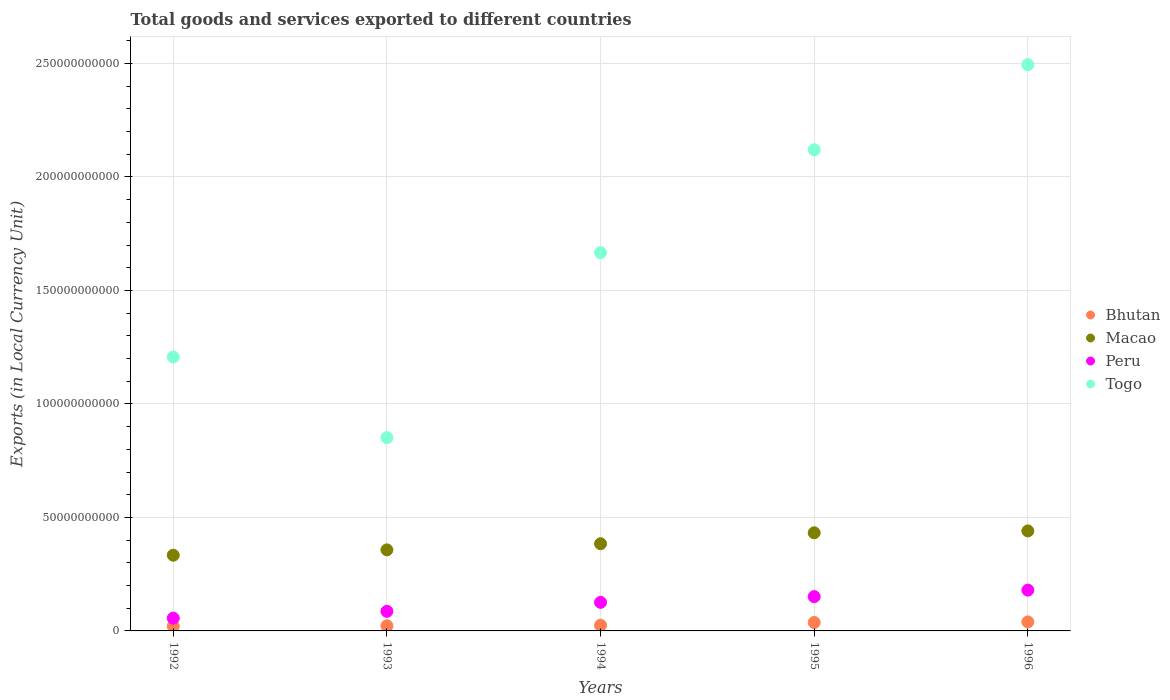What is the Amount of goods and services exports in Macao in 1995?
Offer a very short reply. 4.32e+1. Across all years, what is the maximum Amount of goods and services exports in Togo?
Your answer should be compact. 2.49e+11. Across all years, what is the minimum Amount of goods and services exports in Bhutan?
Make the answer very short. 2.08e+09. In which year was the Amount of goods and services exports in Togo maximum?
Provide a short and direct response. 1996. In which year was the Amount of goods and services exports in Togo minimum?
Give a very brief answer. 1993. What is the total Amount of goods and services exports in Peru in the graph?
Make the answer very short. 5.99e+1. What is the difference between the Amount of goods and services exports in Macao in 1993 and that in 1994?
Your answer should be compact. -2.71e+09. What is the difference between the Amount of goods and services exports in Peru in 1992 and the Amount of goods and services exports in Macao in 1996?
Provide a short and direct response. -3.84e+1. What is the average Amount of goods and services exports in Bhutan per year?
Make the answer very short. 2.91e+09. In the year 1994, what is the difference between the Amount of goods and services exports in Macao and Amount of goods and services exports in Bhutan?
Ensure brevity in your answer.  3.59e+1. In how many years, is the Amount of goods and services exports in Macao greater than 220000000000 LCU?
Ensure brevity in your answer.  0. What is the ratio of the Amount of goods and services exports in Togo in 1992 to that in 1994?
Provide a short and direct response. 0.72. Is the Amount of goods and services exports in Bhutan in 1994 less than that in 1996?
Your response must be concise. Yes. Is the difference between the Amount of goods and services exports in Macao in 1995 and 1996 greater than the difference between the Amount of goods and services exports in Bhutan in 1995 and 1996?
Ensure brevity in your answer.  No. What is the difference between the highest and the second highest Amount of goods and services exports in Bhutan?
Make the answer very short. 2.67e+08. What is the difference between the highest and the lowest Amount of goods and services exports in Macao?
Make the answer very short. 1.07e+1. In how many years, is the Amount of goods and services exports in Peru greater than the average Amount of goods and services exports in Peru taken over all years?
Offer a very short reply. 3. Is the sum of the Amount of goods and services exports in Bhutan in 1993 and 1996 greater than the maximum Amount of goods and services exports in Peru across all years?
Your response must be concise. No. Is it the case that in every year, the sum of the Amount of goods and services exports in Peru and Amount of goods and services exports in Bhutan  is greater than the sum of Amount of goods and services exports in Togo and Amount of goods and services exports in Macao?
Your answer should be compact. Yes. Does the Amount of goods and services exports in Macao monotonically increase over the years?
Offer a very short reply. Yes. What is the difference between two consecutive major ticks on the Y-axis?
Your answer should be very brief. 5.00e+1. Are the values on the major ticks of Y-axis written in scientific E-notation?
Ensure brevity in your answer.  No. Does the graph contain any zero values?
Keep it short and to the point. No. Does the graph contain grids?
Provide a succinct answer. Yes. Where does the legend appear in the graph?
Ensure brevity in your answer.  Center right. What is the title of the graph?
Offer a very short reply. Total goods and services exported to different countries. What is the label or title of the Y-axis?
Your response must be concise. Exports (in Local Currency Unit). What is the Exports (in Local Currency Unit) of Bhutan in 1992?
Give a very brief answer. 2.08e+09. What is the Exports (in Local Currency Unit) in Macao in 1992?
Your answer should be compact. 3.34e+1. What is the Exports (in Local Currency Unit) of Peru in 1992?
Provide a succinct answer. 5.63e+09. What is the Exports (in Local Currency Unit) of Togo in 1992?
Provide a short and direct response. 1.21e+11. What is the Exports (in Local Currency Unit) in Bhutan in 1993?
Your answer should be compact. 2.26e+09. What is the Exports (in Local Currency Unit) in Macao in 1993?
Make the answer very short. 3.57e+1. What is the Exports (in Local Currency Unit) in Peru in 1993?
Offer a terse response. 8.63e+09. What is the Exports (in Local Currency Unit) in Togo in 1993?
Offer a terse response. 8.52e+1. What is the Exports (in Local Currency Unit) in Bhutan in 1994?
Provide a succinct answer. 2.51e+09. What is the Exports (in Local Currency Unit) in Macao in 1994?
Offer a very short reply. 3.84e+1. What is the Exports (in Local Currency Unit) of Peru in 1994?
Your answer should be compact. 1.26e+1. What is the Exports (in Local Currency Unit) of Togo in 1994?
Keep it short and to the point. 1.67e+11. What is the Exports (in Local Currency Unit) of Bhutan in 1995?
Your response must be concise. 3.71e+09. What is the Exports (in Local Currency Unit) of Macao in 1995?
Keep it short and to the point. 4.32e+1. What is the Exports (in Local Currency Unit) of Peru in 1995?
Keep it short and to the point. 1.51e+1. What is the Exports (in Local Currency Unit) of Togo in 1995?
Your answer should be compact. 2.12e+11. What is the Exports (in Local Currency Unit) in Bhutan in 1996?
Ensure brevity in your answer.  3.98e+09. What is the Exports (in Local Currency Unit) of Macao in 1996?
Offer a very short reply. 4.41e+1. What is the Exports (in Local Currency Unit) in Peru in 1996?
Provide a succinct answer. 1.80e+1. What is the Exports (in Local Currency Unit) in Togo in 1996?
Provide a succinct answer. 2.49e+11. Across all years, what is the maximum Exports (in Local Currency Unit) of Bhutan?
Your answer should be very brief. 3.98e+09. Across all years, what is the maximum Exports (in Local Currency Unit) in Macao?
Keep it short and to the point. 4.41e+1. Across all years, what is the maximum Exports (in Local Currency Unit) in Peru?
Offer a terse response. 1.80e+1. Across all years, what is the maximum Exports (in Local Currency Unit) of Togo?
Keep it short and to the point. 2.49e+11. Across all years, what is the minimum Exports (in Local Currency Unit) of Bhutan?
Your answer should be very brief. 2.08e+09. Across all years, what is the minimum Exports (in Local Currency Unit) in Macao?
Offer a very short reply. 3.34e+1. Across all years, what is the minimum Exports (in Local Currency Unit) of Peru?
Make the answer very short. 5.63e+09. Across all years, what is the minimum Exports (in Local Currency Unit) of Togo?
Give a very brief answer. 8.52e+1. What is the total Exports (in Local Currency Unit) of Bhutan in the graph?
Offer a terse response. 1.45e+1. What is the total Exports (in Local Currency Unit) of Macao in the graph?
Your answer should be compact. 1.95e+11. What is the total Exports (in Local Currency Unit) in Peru in the graph?
Provide a short and direct response. 5.99e+1. What is the total Exports (in Local Currency Unit) of Togo in the graph?
Your response must be concise. 8.34e+11. What is the difference between the Exports (in Local Currency Unit) in Bhutan in 1992 and that in 1993?
Your answer should be compact. -1.85e+08. What is the difference between the Exports (in Local Currency Unit) in Macao in 1992 and that in 1993?
Your answer should be compact. -2.35e+09. What is the difference between the Exports (in Local Currency Unit) of Peru in 1992 and that in 1993?
Provide a short and direct response. -3.00e+09. What is the difference between the Exports (in Local Currency Unit) in Togo in 1992 and that in 1993?
Your answer should be very brief. 3.55e+1. What is the difference between the Exports (in Local Currency Unit) of Bhutan in 1992 and that in 1994?
Your answer should be compact. -4.29e+08. What is the difference between the Exports (in Local Currency Unit) of Macao in 1992 and that in 1994?
Offer a terse response. -5.06e+09. What is the difference between the Exports (in Local Currency Unit) in Peru in 1992 and that in 1994?
Ensure brevity in your answer.  -6.96e+09. What is the difference between the Exports (in Local Currency Unit) in Togo in 1992 and that in 1994?
Make the answer very short. -4.60e+1. What is the difference between the Exports (in Local Currency Unit) of Bhutan in 1992 and that in 1995?
Keep it short and to the point. -1.63e+09. What is the difference between the Exports (in Local Currency Unit) of Macao in 1992 and that in 1995?
Provide a succinct answer. -9.87e+09. What is the difference between the Exports (in Local Currency Unit) of Peru in 1992 and that in 1995?
Offer a terse response. -9.49e+09. What is the difference between the Exports (in Local Currency Unit) in Togo in 1992 and that in 1995?
Your response must be concise. -9.13e+1. What is the difference between the Exports (in Local Currency Unit) of Bhutan in 1992 and that in 1996?
Provide a short and direct response. -1.90e+09. What is the difference between the Exports (in Local Currency Unit) in Macao in 1992 and that in 1996?
Ensure brevity in your answer.  -1.07e+1. What is the difference between the Exports (in Local Currency Unit) of Peru in 1992 and that in 1996?
Your response must be concise. -1.23e+1. What is the difference between the Exports (in Local Currency Unit) in Togo in 1992 and that in 1996?
Offer a terse response. -1.29e+11. What is the difference between the Exports (in Local Currency Unit) in Bhutan in 1993 and that in 1994?
Make the answer very short. -2.44e+08. What is the difference between the Exports (in Local Currency Unit) of Macao in 1993 and that in 1994?
Make the answer very short. -2.71e+09. What is the difference between the Exports (in Local Currency Unit) in Peru in 1993 and that in 1994?
Provide a succinct answer. -3.96e+09. What is the difference between the Exports (in Local Currency Unit) of Togo in 1993 and that in 1994?
Your answer should be compact. -8.15e+1. What is the difference between the Exports (in Local Currency Unit) in Bhutan in 1993 and that in 1995?
Make the answer very short. -1.45e+09. What is the difference between the Exports (in Local Currency Unit) in Macao in 1993 and that in 1995?
Your response must be concise. -7.52e+09. What is the difference between the Exports (in Local Currency Unit) of Peru in 1993 and that in 1995?
Provide a short and direct response. -6.49e+09. What is the difference between the Exports (in Local Currency Unit) of Togo in 1993 and that in 1995?
Provide a short and direct response. -1.27e+11. What is the difference between the Exports (in Local Currency Unit) in Bhutan in 1993 and that in 1996?
Ensure brevity in your answer.  -1.71e+09. What is the difference between the Exports (in Local Currency Unit) in Macao in 1993 and that in 1996?
Your answer should be very brief. -8.35e+09. What is the difference between the Exports (in Local Currency Unit) of Peru in 1993 and that in 1996?
Offer a very short reply. -9.35e+09. What is the difference between the Exports (in Local Currency Unit) of Togo in 1993 and that in 1996?
Offer a very short reply. -1.64e+11. What is the difference between the Exports (in Local Currency Unit) in Bhutan in 1994 and that in 1995?
Your answer should be very brief. -1.20e+09. What is the difference between the Exports (in Local Currency Unit) in Macao in 1994 and that in 1995?
Provide a short and direct response. -4.81e+09. What is the difference between the Exports (in Local Currency Unit) of Peru in 1994 and that in 1995?
Keep it short and to the point. -2.53e+09. What is the difference between the Exports (in Local Currency Unit) of Togo in 1994 and that in 1995?
Provide a short and direct response. -4.53e+1. What is the difference between the Exports (in Local Currency Unit) in Bhutan in 1994 and that in 1996?
Your answer should be compact. -1.47e+09. What is the difference between the Exports (in Local Currency Unit) of Macao in 1994 and that in 1996?
Give a very brief answer. -5.64e+09. What is the difference between the Exports (in Local Currency Unit) in Peru in 1994 and that in 1996?
Offer a very short reply. -5.38e+09. What is the difference between the Exports (in Local Currency Unit) of Togo in 1994 and that in 1996?
Your response must be concise. -8.28e+1. What is the difference between the Exports (in Local Currency Unit) in Bhutan in 1995 and that in 1996?
Make the answer very short. -2.67e+08. What is the difference between the Exports (in Local Currency Unit) of Macao in 1995 and that in 1996?
Make the answer very short. -8.31e+08. What is the difference between the Exports (in Local Currency Unit) of Peru in 1995 and that in 1996?
Give a very brief answer. -2.86e+09. What is the difference between the Exports (in Local Currency Unit) of Togo in 1995 and that in 1996?
Offer a very short reply. -3.75e+1. What is the difference between the Exports (in Local Currency Unit) of Bhutan in 1992 and the Exports (in Local Currency Unit) of Macao in 1993?
Offer a terse response. -3.36e+1. What is the difference between the Exports (in Local Currency Unit) in Bhutan in 1992 and the Exports (in Local Currency Unit) in Peru in 1993?
Give a very brief answer. -6.55e+09. What is the difference between the Exports (in Local Currency Unit) in Bhutan in 1992 and the Exports (in Local Currency Unit) in Togo in 1993?
Offer a terse response. -8.31e+1. What is the difference between the Exports (in Local Currency Unit) in Macao in 1992 and the Exports (in Local Currency Unit) in Peru in 1993?
Offer a very short reply. 2.47e+1. What is the difference between the Exports (in Local Currency Unit) in Macao in 1992 and the Exports (in Local Currency Unit) in Togo in 1993?
Offer a terse response. -5.18e+1. What is the difference between the Exports (in Local Currency Unit) of Peru in 1992 and the Exports (in Local Currency Unit) of Togo in 1993?
Provide a short and direct response. -7.95e+1. What is the difference between the Exports (in Local Currency Unit) of Bhutan in 1992 and the Exports (in Local Currency Unit) of Macao in 1994?
Keep it short and to the point. -3.63e+1. What is the difference between the Exports (in Local Currency Unit) in Bhutan in 1992 and the Exports (in Local Currency Unit) in Peru in 1994?
Your answer should be very brief. -1.05e+1. What is the difference between the Exports (in Local Currency Unit) in Bhutan in 1992 and the Exports (in Local Currency Unit) in Togo in 1994?
Your answer should be compact. -1.65e+11. What is the difference between the Exports (in Local Currency Unit) in Macao in 1992 and the Exports (in Local Currency Unit) in Peru in 1994?
Your response must be concise. 2.08e+1. What is the difference between the Exports (in Local Currency Unit) in Macao in 1992 and the Exports (in Local Currency Unit) in Togo in 1994?
Provide a succinct answer. -1.33e+11. What is the difference between the Exports (in Local Currency Unit) of Peru in 1992 and the Exports (in Local Currency Unit) of Togo in 1994?
Offer a terse response. -1.61e+11. What is the difference between the Exports (in Local Currency Unit) in Bhutan in 1992 and the Exports (in Local Currency Unit) in Macao in 1995?
Your answer should be compact. -4.12e+1. What is the difference between the Exports (in Local Currency Unit) in Bhutan in 1992 and the Exports (in Local Currency Unit) in Peru in 1995?
Keep it short and to the point. -1.30e+1. What is the difference between the Exports (in Local Currency Unit) in Bhutan in 1992 and the Exports (in Local Currency Unit) in Togo in 1995?
Provide a succinct answer. -2.10e+11. What is the difference between the Exports (in Local Currency Unit) of Macao in 1992 and the Exports (in Local Currency Unit) of Peru in 1995?
Make the answer very short. 1.82e+1. What is the difference between the Exports (in Local Currency Unit) of Macao in 1992 and the Exports (in Local Currency Unit) of Togo in 1995?
Provide a succinct answer. -1.79e+11. What is the difference between the Exports (in Local Currency Unit) of Peru in 1992 and the Exports (in Local Currency Unit) of Togo in 1995?
Give a very brief answer. -2.06e+11. What is the difference between the Exports (in Local Currency Unit) of Bhutan in 1992 and the Exports (in Local Currency Unit) of Macao in 1996?
Give a very brief answer. -4.20e+1. What is the difference between the Exports (in Local Currency Unit) in Bhutan in 1992 and the Exports (in Local Currency Unit) in Peru in 1996?
Your answer should be very brief. -1.59e+1. What is the difference between the Exports (in Local Currency Unit) of Bhutan in 1992 and the Exports (in Local Currency Unit) of Togo in 1996?
Ensure brevity in your answer.  -2.47e+11. What is the difference between the Exports (in Local Currency Unit) in Macao in 1992 and the Exports (in Local Currency Unit) in Peru in 1996?
Ensure brevity in your answer.  1.54e+1. What is the difference between the Exports (in Local Currency Unit) in Macao in 1992 and the Exports (in Local Currency Unit) in Togo in 1996?
Give a very brief answer. -2.16e+11. What is the difference between the Exports (in Local Currency Unit) of Peru in 1992 and the Exports (in Local Currency Unit) of Togo in 1996?
Give a very brief answer. -2.44e+11. What is the difference between the Exports (in Local Currency Unit) in Bhutan in 1993 and the Exports (in Local Currency Unit) in Macao in 1994?
Provide a succinct answer. -3.62e+1. What is the difference between the Exports (in Local Currency Unit) in Bhutan in 1993 and the Exports (in Local Currency Unit) in Peru in 1994?
Keep it short and to the point. -1.03e+1. What is the difference between the Exports (in Local Currency Unit) of Bhutan in 1993 and the Exports (in Local Currency Unit) of Togo in 1994?
Offer a very short reply. -1.64e+11. What is the difference between the Exports (in Local Currency Unit) of Macao in 1993 and the Exports (in Local Currency Unit) of Peru in 1994?
Ensure brevity in your answer.  2.31e+1. What is the difference between the Exports (in Local Currency Unit) of Macao in 1993 and the Exports (in Local Currency Unit) of Togo in 1994?
Keep it short and to the point. -1.31e+11. What is the difference between the Exports (in Local Currency Unit) of Peru in 1993 and the Exports (in Local Currency Unit) of Togo in 1994?
Make the answer very short. -1.58e+11. What is the difference between the Exports (in Local Currency Unit) in Bhutan in 1993 and the Exports (in Local Currency Unit) in Macao in 1995?
Provide a short and direct response. -4.10e+1. What is the difference between the Exports (in Local Currency Unit) in Bhutan in 1993 and the Exports (in Local Currency Unit) in Peru in 1995?
Provide a short and direct response. -1.29e+1. What is the difference between the Exports (in Local Currency Unit) of Bhutan in 1993 and the Exports (in Local Currency Unit) of Togo in 1995?
Your response must be concise. -2.10e+11. What is the difference between the Exports (in Local Currency Unit) in Macao in 1993 and the Exports (in Local Currency Unit) in Peru in 1995?
Your response must be concise. 2.06e+1. What is the difference between the Exports (in Local Currency Unit) of Macao in 1993 and the Exports (in Local Currency Unit) of Togo in 1995?
Make the answer very short. -1.76e+11. What is the difference between the Exports (in Local Currency Unit) in Peru in 1993 and the Exports (in Local Currency Unit) in Togo in 1995?
Your answer should be very brief. -2.03e+11. What is the difference between the Exports (in Local Currency Unit) in Bhutan in 1993 and the Exports (in Local Currency Unit) in Macao in 1996?
Ensure brevity in your answer.  -4.18e+1. What is the difference between the Exports (in Local Currency Unit) in Bhutan in 1993 and the Exports (in Local Currency Unit) in Peru in 1996?
Keep it short and to the point. -1.57e+1. What is the difference between the Exports (in Local Currency Unit) of Bhutan in 1993 and the Exports (in Local Currency Unit) of Togo in 1996?
Your answer should be compact. -2.47e+11. What is the difference between the Exports (in Local Currency Unit) in Macao in 1993 and the Exports (in Local Currency Unit) in Peru in 1996?
Your answer should be compact. 1.77e+1. What is the difference between the Exports (in Local Currency Unit) in Macao in 1993 and the Exports (in Local Currency Unit) in Togo in 1996?
Keep it short and to the point. -2.14e+11. What is the difference between the Exports (in Local Currency Unit) of Peru in 1993 and the Exports (in Local Currency Unit) of Togo in 1996?
Provide a succinct answer. -2.41e+11. What is the difference between the Exports (in Local Currency Unit) of Bhutan in 1994 and the Exports (in Local Currency Unit) of Macao in 1995?
Your answer should be very brief. -4.07e+1. What is the difference between the Exports (in Local Currency Unit) of Bhutan in 1994 and the Exports (in Local Currency Unit) of Peru in 1995?
Your response must be concise. -1.26e+1. What is the difference between the Exports (in Local Currency Unit) in Bhutan in 1994 and the Exports (in Local Currency Unit) in Togo in 1995?
Offer a very short reply. -2.09e+11. What is the difference between the Exports (in Local Currency Unit) of Macao in 1994 and the Exports (in Local Currency Unit) of Peru in 1995?
Give a very brief answer. 2.33e+1. What is the difference between the Exports (in Local Currency Unit) in Macao in 1994 and the Exports (in Local Currency Unit) in Togo in 1995?
Offer a very short reply. -1.74e+11. What is the difference between the Exports (in Local Currency Unit) in Peru in 1994 and the Exports (in Local Currency Unit) in Togo in 1995?
Offer a very short reply. -1.99e+11. What is the difference between the Exports (in Local Currency Unit) of Bhutan in 1994 and the Exports (in Local Currency Unit) of Macao in 1996?
Your answer should be very brief. -4.16e+1. What is the difference between the Exports (in Local Currency Unit) of Bhutan in 1994 and the Exports (in Local Currency Unit) of Peru in 1996?
Ensure brevity in your answer.  -1.55e+1. What is the difference between the Exports (in Local Currency Unit) in Bhutan in 1994 and the Exports (in Local Currency Unit) in Togo in 1996?
Your response must be concise. -2.47e+11. What is the difference between the Exports (in Local Currency Unit) in Macao in 1994 and the Exports (in Local Currency Unit) in Peru in 1996?
Your response must be concise. 2.04e+1. What is the difference between the Exports (in Local Currency Unit) of Macao in 1994 and the Exports (in Local Currency Unit) of Togo in 1996?
Provide a succinct answer. -2.11e+11. What is the difference between the Exports (in Local Currency Unit) of Peru in 1994 and the Exports (in Local Currency Unit) of Togo in 1996?
Provide a succinct answer. -2.37e+11. What is the difference between the Exports (in Local Currency Unit) of Bhutan in 1995 and the Exports (in Local Currency Unit) of Macao in 1996?
Your response must be concise. -4.04e+1. What is the difference between the Exports (in Local Currency Unit) in Bhutan in 1995 and the Exports (in Local Currency Unit) in Peru in 1996?
Provide a short and direct response. -1.43e+1. What is the difference between the Exports (in Local Currency Unit) of Bhutan in 1995 and the Exports (in Local Currency Unit) of Togo in 1996?
Keep it short and to the point. -2.46e+11. What is the difference between the Exports (in Local Currency Unit) in Macao in 1995 and the Exports (in Local Currency Unit) in Peru in 1996?
Provide a short and direct response. 2.53e+1. What is the difference between the Exports (in Local Currency Unit) of Macao in 1995 and the Exports (in Local Currency Unit) of Togo in 1996?
Your answer should be very brief. -2.06e+11. What is the difference between the Exports (in Local Currency Unit) in Peru in 1995 and the Exports (in Local Currency Unit) in Togo in 1996?
Provide a short and direct response. -2.34e+11. What is the average Exports (in Local Currency Unit) in Bhutan per year?
Your response must be concise. 2.91e+09. What is the average Exports (in Local Currency Unit) of Macao per year?
Offer a very short reply. 3.90e+1. What is the average Exports (in Local Currency Unit) in Peru per year?
Give a very brief answer. 1.20e+1. What is the average Exports (in Local Currency Unit) in Togo per year?
Your response must be concise. 1.67e+11. In the year 1992, what is the difference between the Exports (in Local Currency Unit) of Bhutan and Exports (in Local Currency Unit) of Macao?
Your answer should be very brief. -3.13e+1. In the year 1992, what is the difference between the Exports (in Local Currency Unit) in Bhutan and Exports (in Local Currency Unit) in Peru?
Offer a terse response. -3.55e+09. In the year 1992, what is the difference between the Exports (in Local Currency Unit) of Bhutan and Exports (in Local Currency Unit) of Togo?
Keep it short and to the point. -1.19e+11. In the year 1992, what is the difference between the Exports (in Local Currency Unit) in Macao and Exports (in Local Currency Unit) in Peru?
Make the answer very short. 2.77e+1. In the year 1992, what is the difference between the Exports (in Local Currency Unit) of Macao and Exports (in Local Currency Unit) of Togo?
Your answer should be compact. -8.73e+1. In the year 1992, what is the difference between the Exports (in Local Currency Unit) of Peru and Exports (in Local Currency Unit) of Togo?
Provide a short and direct response. -1.15e+11. In the year 1993, what is the difference between the Exports (in Local Currency Unit) in Bhutan and Exports (in Local Currency Unit) in Macao?
Provide a short and direct response. -3.34e+1. In the year 1993, what is the difference between the Exports (in Local Currency Unit) of Bhutan and Exports (in Local Currency Unit) of Peru?
Your answer should be compact. -6.36e+09. In the year 1993, what is the difference between the Exports (in Local Currency Unit) of Bhutan and Exports (in Local Currency Unit) of Togo?
Provide a short and direct response. -8.29e+1. In the year 1993, what is the difference between the Exports (in Local Currency Unit) in Macao and Exports (in Local Currency Unit) in Peru?
Ensure brevity in your answer.  2.71e+1. In the year 1993, what is the difference between the Exports (in Local Currency Unit) of Macao and Exports (in Local Currency Unit) of Togo?
Offer a terse response. -4.95e+1. In the year 1993, what is the difference between the Exports (in Local Currency Unit) of Peru and Exports (in Local Currency Unit) of Togo?
Your answer should be very brief. -7.65e+1. In the year 1994, what is the difference between the Exports (in Local Currency Unit) of Bhutan and Exports (in Local Currency Unit) of Macao?
Keep it short and to the point. -3.59e+1. In the year 1994, what is the difference between the Exports (in Local Currency Unit) of Bhutan and Exports (in Local Currency Unit) of Peru?
Offer a very short reply. -1.01e+1. In the year 1994, what is the difference between the Exports (in Local Currency Unit) of Bhutan and Exports (in Local Currency Unit) of Togo?
Your response must be concise. -1.64e+11. In the year 1994, what is the difference between the Exports (in Local Currency Unit) of Macao and Exports (in Local Currency Unit) of Peru?
Your answer should be very brief. 2.58e+1. In the year 1994, what is the difference between the Exports (in Local Currency Unit) in Macao and Exports (in Local Currency Unit) in Togo?
Offer a terse response. -1.28e+11. In the year 1994, what is the difference between the Exports (in Local Currency Unit) in Peru and Exports (in Local Currency Unit) in Togo?
Keep it short and to the point. -1.54e+11. In the year 1995, what is the difference between the Exports (in Local Currency Unit) of Bhutan and Exports (in Local Currency Unit) of Macao?
Your answer should be compact. -3.95e+1. In the year 1995, what is the difference between the Exports (in Local Currency Unit) of Bhutan and Exports (in Local Currency Unit) of Peru?
Offer a terse response. -1.14e+1. In the year 1995, what is the difference between the Exports (in Local Currency Unit) of Bhutan and Exports (in Local Currency Unit) of Togo?
Your answer should be compact. -2.08e+11. In the year 1995, what is the difference between the Exports (in Local Currency Unit) in Macao and Exports (in Local Currency Unit) in Peru?
Ensure brevity in your answer.  2.81e+1. In the year 1995, what is the difference between the Exports (in Local Currency Unit) in Macao and Exports (in Local Currency Unit) in Togo?
Provide a succinct answer. -1.69e+11. In the year 1995, what is the difference between the Exports (in Local Currency Unit) in Peru and Exports (in Local Currency Unit) in Togo?
Keep it short and to the point. -1.97e+11. In the year 1996, what is the difference between the Exports (in Local Currency Unit) of Bhutan and Exports (in Local Currency Unit) of Macao?
Offer a very short reply. -4.01e+1. In the year 1996, what is the difference between the Exports (in Local Currency Unit) in Bhutan and Exports (in Local Currency Unit) in Peru?
Keep it short and to the point. -1.40e+1. In the year 1996, what is the difference between the Exports (in Local Currency Unit) in Bhutan and Exports (in Local Currency Unit) in Togo?
Make the answer very short. -2.46e+11. In the year 1996, what is the difference between the Exports (in Local Currency Unit) in Macao and Exports (in Local Currency Unit) in Peru?
Make the answer very short. 2.61e+1. In the year 1996, what is the difference between the Exports (in Local Currency Unit) in Macao and Exports (in Local Currency Unit) in Togo?
Provide a succinct answer. -2.05e+11. In the year 1996, what is the difference between the Exports (in Local Currency Unit) in Peru and Exports (in Local Currency Unit) in Togo?
Offer a terse response. -2.32e+11. What is the ratio of the Exports (in Local Currency Unit) in Bhutan in 1992 to that in 1993?
Ensure brevity in your answer.  0.92. What is the ratio of the Exports (in Local Currency Unit) of Macao in 1992 to that in 1993?
Your answer should be compact. 0.93. What is the ratio of the Exports (in Local Currency Unit) in Peru in 1992 to that in 1993?
Provide a short and direct response. 0.65. What is the ratio of the Exports (in Local Currency Unit) of Togo in 1992 to that in 1993?
Offer a very short reply. 1.42. What is the ratio of the Exports (in Local Currency Unit) of Bhutan in 1992 to that in 1994?
Your answer should be very brief. 0.83. What is the ratio of the Exports (in Local Currency Unit) of Macao in 1992 to that in 1994?
Ensure brevity in your answer.  0.87. What is the ratio of the Exports (in Local Currency Unit) in Peru in 1992 to that in 1994?
Offer a terse response. 0.45. What is the ratio of the Exports (in Local Currency Unit) of Togo in 1992 to that in 1994?
Offer a very short reply. 0.72. What is the ratio of the Exports (in Local Currency Unit) of Bhutan in 1992 to that in 1995?
Give a very brief answer. 0.56. What is the ratio of the Exports (in Local Currency Unit) of Macao in 1992 to that in 1995?
Ensure brevity in your answer.  0.77. What is the ratio of the Exports (in Local Currency Unit) in Peru in 1992 to that in 1995?
Ensure brevity in your answer.  0.37. What is the ratio of the Exports (in Local Currency Unit) in Togo in 1992 to that in 1995?
Your response must be concise. 0.57. What is the ratio of the Exports (in Local Currency Unit) in Bhutan in 1992 to that in 1996?
Keep it short and to the point. 0.52. What is the ratio of the Exports (in Local Currency Unit) of Macao in 1992 to that in 1996?
Keep it short and to the point. 0.76. What is the ratio of the Exports (in Local Currency Unit) in Peru in 1992 to that in 1996?
Make the answer very short. 0.31. What is the ratio of the Exports (in Local Currency Unit) in Togo in 1992 to that in 1996?
Provide a succinct answer. 0.48. What is the ratio of the Exports (in Local Currency Unit) of Bhutan in 1993 to that in 1994?
Offer a very short reply. 0.9. What is the ratio of the Exports (in Local Currency Unit) in Macao in 1993 to that in 1994?
Your answer should be compact. 0.93. What is the ratio of the Exports (in Local Currency Unit) of Peru in 1993 to that in 1994?
Your answer should be very brief. 0.69. What is the ratio of the Exports (in Local Currency Unit) in Togo in 1993 to that in 1994?
Keep it short and to the point. 0.51. What is the ratio of the Exports (in Local Currency Unit) of Bhutan in 1993 to that in 1995?
Offer a terse response. 0.61. What is the ratio of the Exports (in Local Currency Unit) of Macao in 1993 to that in 1995?
Make the answer very short. 0.83. What is the ratio of the Exports (in Local Currency Unit) of Peru in 1993 to that in 1995?
Offer a very short reply. 0.57. What is the ratio of the Exports (in Local Currency Unit) in Togo in 1993 to that in 1995?
Keep it short and to the point. 0.4. What is the ratio of the Exports (in Local Currency Unit) in Bhutan in 1993 to that in 1996?
Offer a very short reply. 0.57. What is the ratio of the Exports (in Local Currency Unit) of Macao in 1993 to that in 1996?
Make the answer very short. 0.81. What is the ratio of the Exports (in Local Currency Unit) in Peru in 1993 to that in 1996?
Give a very brief answer. 0.48. What is the ratio of the Exports (in Local Currency Unit) of Togo in 1993 to that in 1996?
Your answer should be very brief. 0.34. What is the ratio of the Exports (in Local Currency Unit) of Bhutan in 1994 to that in 1995?
Your answer should be compact. 0.68. What is the ratio of the Exports (in Local Currency Unit) of Macao in 1994 to that in 1995?
Your answer should be very brief. 0.89. What is the ratio of the Exports (in Local Currency Unit) in Peru in 1994 to that in 1995?
Ensure brevity in your answer.  0.83. What is the ratio of the Exports (in Local Currency Unit) of Togo in 1994 to that in 1995?
Provide a succinct answer. 0.79. What is the ratio of the Exports (in Local Currency Unit) in Bhutan in 1994 to that in 1996?
Provide a succinct answer. 0.63. What is the ratio of the Exports (in Local Currency Unit) of Macao in 1994 to that in 1996?
Ensure brevity in your answer.  0.87. What is the ratio of the Exports (in Local Currency Unit) in Peru in 1994 to that in 1996?
Your answer should be very brief. 0.7. What is the ratio of the Exports (in Local Currency Unit) of Togo in 1994 to that in 1996?
Make the answer very short. 0.67. What is the ratio of the Exports (in Local Currency Unit) of Bhutan in 1995 to that in 1996?
Give a very brief answer. 0.93. What is the ratio of the Exports (in Local Currency Unit) in Macao in 1995 to that in 1996?
Your answer should be very brief. 0.98. What is the ratio of the Exports (in Local Currency Unit) in Peru in 1995 to that in 1996?
Provide a short and direct response. 0.84. What is the ratio of the Exports (in Local Currency Unit) in Togo in 1995 to that in 1996?
Provide a short and direct response. 0.85. What is the difference between the highest and the second highest Exports (in Local Currency Unit) of Bhutan?
Give a very brief answer. 2.67e+08. What is the difference between the highest and the second highest Exports (in Local Currency Unit) in Macao?
Your response must be concise. 8.31e+08. What is the difference between the highest and the second highest Exports (in Local Currency Unit) of Peru?
Your answer should be very brief. 2.86e+09. What is the difference between the highest and the second highest Exports (in Local Currency Unit) of Togo?
Keep it short and to the point. 3.75e+1. What is the difference between the highest and the lowest Exports (in Local Currency Unit) in Bhutan?
Offer a terse response. 1.90e+09. What is the difference between the highest and the lowest Exports (in Local Currency Unit) in Macao?
Offer a very short reply. 1.07e+1. What is the difference between the highest and the lowest Exports (in Local Currency Unit) of Peru?
Make the answer very short. 1.23e+1. What is the difference between the highest and the lowest Exports (in Local Currency Unit) in Togo?
Ensure brevity in your answer.  1.64e+11. 